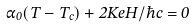<formula> <loc_0><loc_0><loc_500><loc_500>\alpha _ { 0 } ( T - T _ { c } ) + 2 K e H / \hbar { c } = 0</formula> 